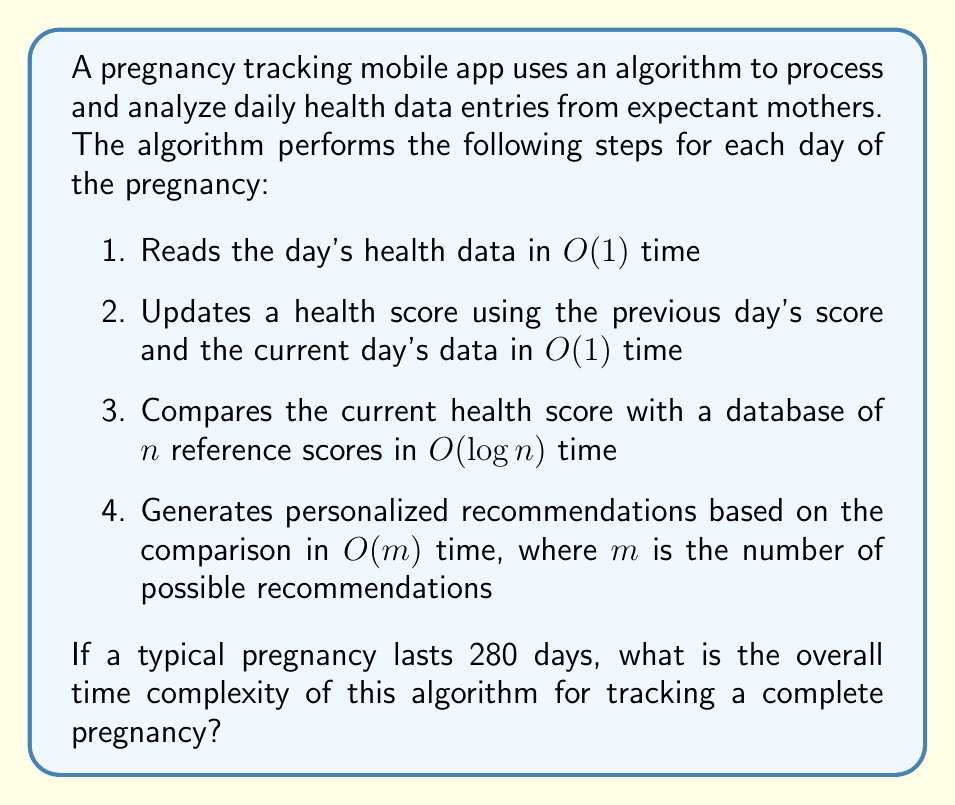What is the answer to this math problem? To determine the overall time complexity, we need to analyze each step of the algorithm and how it's applied over the course of a pregnancy:

1. The daily health data reading is $O(1)$ for each day.
2. Updating the health score is also $O(1)$ for each day.
3. Comparing with the database takes $O(\log n)$ time each day.
4. Generating recommendations takes $O(m)$ time each day.

For a single day, the time complexity is:

$$O(1) + O(1) + O(\log n) + O(m) = O(\log n + m)$$

Now, we need to consider that this process is repeated for each day of the pregnancy. Given that a typical pregnancy lasts 280 days, we multiply the daily complexity by 280:

$$280 \cdot O(\log n + m) = O(280 \log n + 280m)$$

Since 280 is a constant, we can simplify this to:

$$O(\log n + m)$$

This represents the overall time complexity for the entire pregnancy tracking process.
Answer: $O(\log n + m)$ 